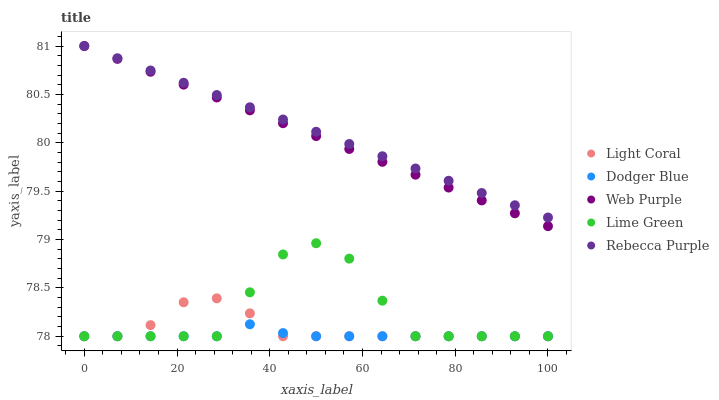Does Dodger Blue have the minimum area under the curve?
Answer yes or no. Yes. Does Rebecca Purple have the maximum area under the curve?
Answer yes or no. Yes. Does Lime Green have the minimum area under the curve?
Answer yes or no. No. Does Lime Green have the maximum area under the curve?
Answer yes or no. No. Is Rebecca Purple the smoothest?
Answer yes or no. Yes. Is Lime Green the roughest?
Answer yes or no. Yes. Is Web Purple the smoothest?
Answer yes or no. No. Is Web Purple the roughest?
Answer yes or no. No. Does Light Coral have the lowest value?
Answer yes or no. Yes. Does Web Purple have the lowest value?
Answer yes or no. No. Does Rebecca Purple have the highest value?
Answer yes or no. Yes. Does Lime Green have the highest value?
Answer yes or no. No. Is Lime Green less than Rebecca Purple?
Answer yes or no. Yes. Is Web Purple greater than Light Coral?
Answer yes or no. Yes. Does Dodger Blue intersect Lime Green?
Answer yes or no. Yes. Is Dodger Blue less than Lime Green?
Answer yes or no. No. Is Dodger Blue greater than Lime Green?
Answer yes or no. No. Does Lime Green intersect Rebecca Purple?
Answer yes or no. No. 